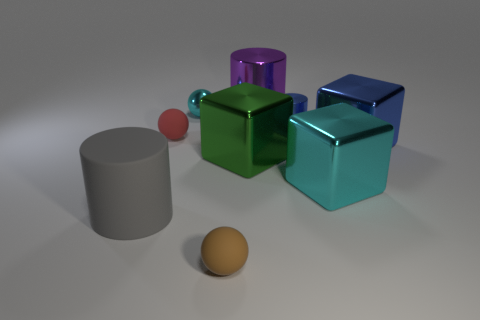What is the large cylinder that is right of the small rubber sphere that is in front of the big gray thing that is on the left side of the red thing made of?
Your answer should be very brief. Metal. Is the number of cyan matte cylinders less than the number of big metallic objects?
Keep it short and to the point. Yes. Do the small cylinder and the large green block have the same material?
Offer a very short reply. Yes. What is the shape of the big thing that is the same color as the metallic sphere?
Offer a terse response. Cube. Is the color of the big shiny thing to the left of the large purple shiny object the same as the small metal ball?
Your answer should be compact. No. There is a large object left of the tiny cyan metallic thing; how many small metallic cylinders are on the left side of it?
Your answer should be compact. 0. The cylinder that is the same size as the cyan shiny ball is what color?
Offer a terse response. Blue. There is a tiny object right of the tiny brown rubber object; what material is it?
Provide a short and direct response. Metal. There is a large thing that is behind the large green object and in front of the cyan metal sphere; what is it made of?
Give a very brief answer. Metal. There is a blue metallic object in front of the red thing; is its size the same as the tiny red rubber sphere?
Provide a short and direct response. No. 